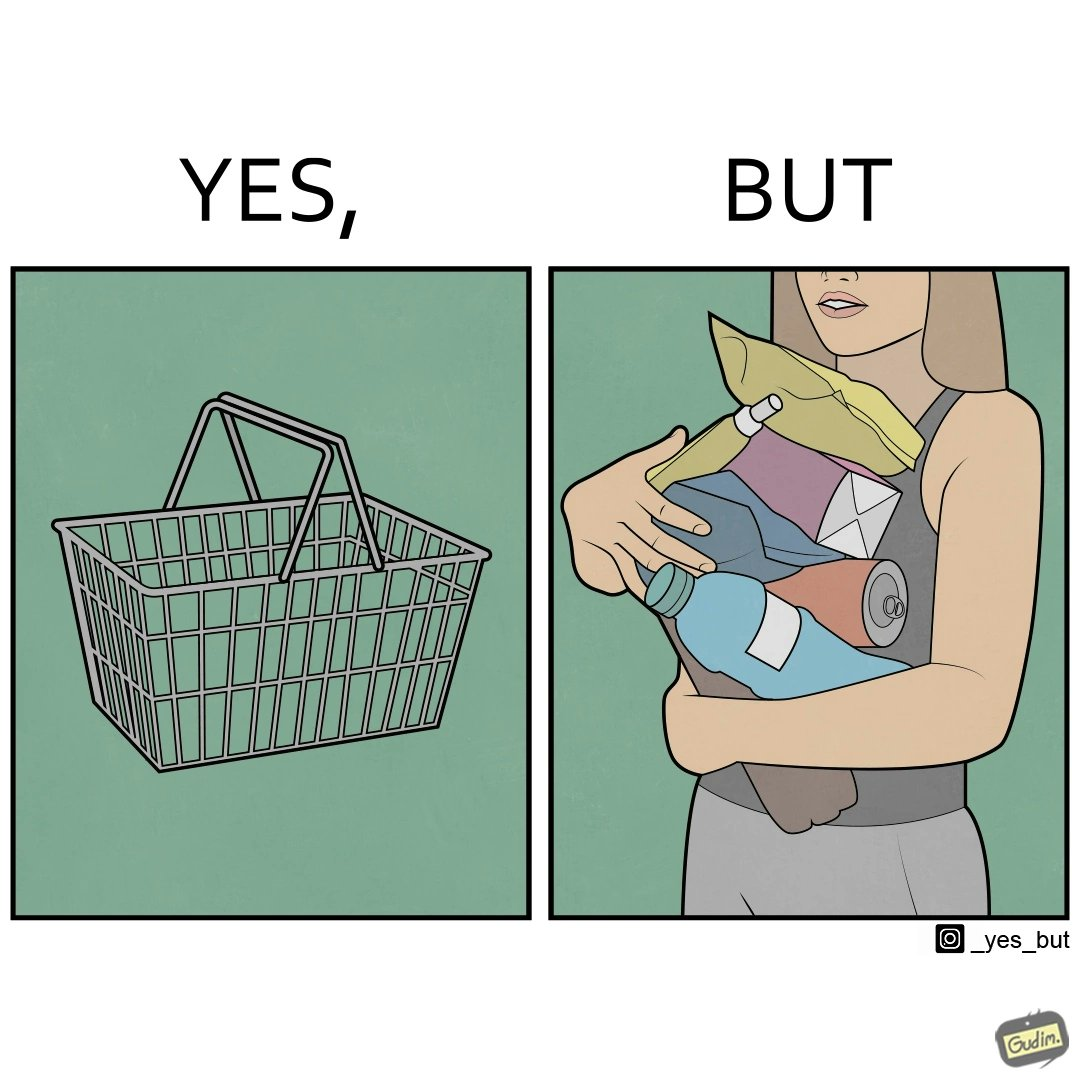Explain the humor or irony in this image. The image is ironic, because even when there are steel frame baskets are available at the supermarkets people prefer carrying the items in hand 